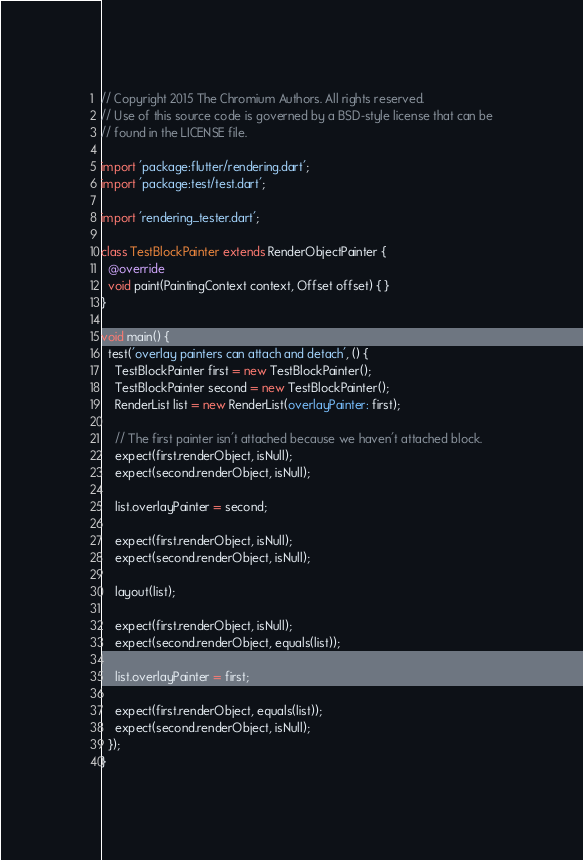Convert code to text. <code><loc_0><loc_0><loc_500><loc_500><_Dart_>// Copyright 2015 The Chromium Authors. All rights reserved.
// Use of this source code is governed by a BSD-style license that can be
// found in the LICENSE file.

import 'package:flutter/rendering.dart';
import 'package:test/test.dart';

import 'rendering_tester.dart';

class TestBlockPainter extends RenderObjectPainter {
  @override
  void paint(PaintingContext context, Offset offset) { }
}

void main() {
  test('overlay painters can attach and detach', () {
    TestBlockPainter first = new TestBlockPainter();
    TestBlockPainter second = new TestBlockPainter();
    RenderList list = new RenderList(overlayPainter: first);

    // The first painter isn't attached because we haven't attached block.
    expect(first.renderObject, isNull);
    expect(second.renderObject, isNull);

    list.overlayPainter = second;

    expect(first.renderObject, isNull);
    expect(second.renderObject, isNull);

    layout(list);

    expect(first.renderObject, isNull);
    expect(second.renderObject, equals(list));

    list.overlayPainter = first;

    expect(first.renderObject, equals(list));
    expect(second.renderObject, isNull);
  });
}
</code> 